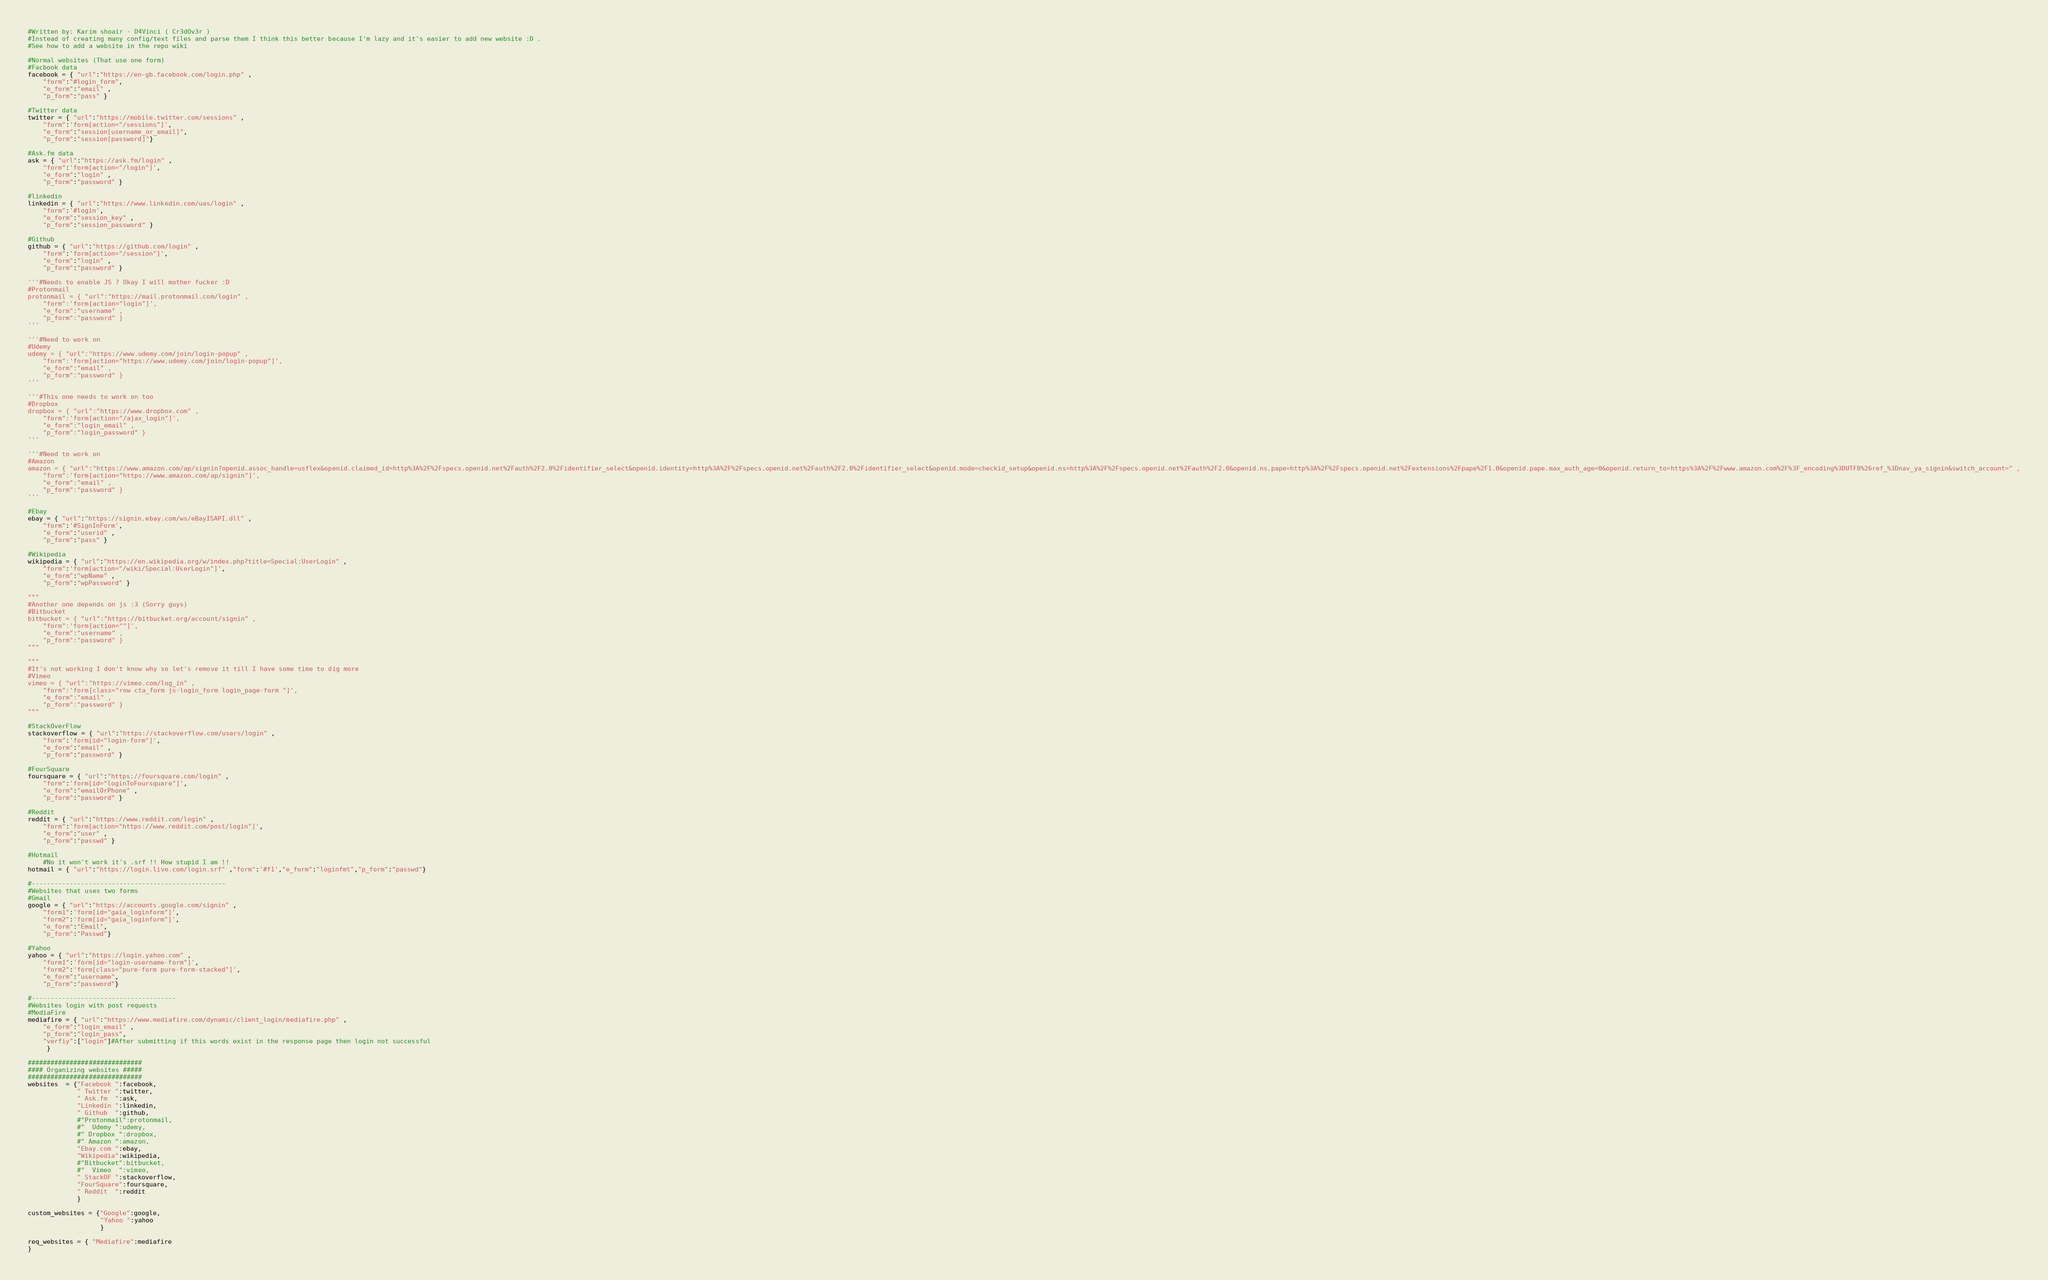<code> <loc_0><loc_0><loc_500><loc_500><_Python_>#Written by: Karim shoair - D4Vinci ( Cr3dOv3r )
#Instead of creating many config/text files and parse them I think this better because I'm lazy and it's easier to add new website :D .
#See how to add a website in the repo wiki

#Normal websites (That use one form)
#Facbook data
facebook = { "url":"https://en-gb.facebook.com/login.php" ,
	"form":"#login_form",
	"e_form":"email" ,
	"p_form":"pass" }

#Twitter data
twitter = { "url":"https://mobile.twitter.com/sessions" ,
	"form":'form[action="/sessions"]',
	"e_form":"session[username_or_email]",
	"p_form":"session[password]"}

#Ask.fm data
ask = { "url":"https://ask.fm/login" ,
	"form":'form[action="/login"]',
	"e_form":"login" ,
	"p_form":"password" }

#linkedin
linkedin = { "url":"https://www.linkedin.com/uas/login" ,
	"form":'#login',
	"e_form":"session_key" ,
	"p_form":"session_password" }

#Github
github = { "url":"https://github.com/login" ,
	"form":'form[action="/session"]',
	"e_form":"login" ,
	"p_form":"password" }

'''#Needs to enable JS ? Okay I will mother fucker :D
#Protonmail
protonmail = { "url":"https://mail.protonmail.com/login" ,
	"form":'form[action="login"]',
	"e_form":"username" ,
	"p_form":"password" }
'''

'''#Need to work on
#Udemy
udemy = { "url":"https://www.udemy.com/join/login-popup" ,
	"form":'form[action="https://www.udemy.com/join/login-popup"]',
	"e_form":"email" ,
	"p_form":"password" }
'''

'''#This one needs to work on too
#Dropbox
dropbox = { "url":"https://www.dropbox.com" ,
	"form":'form[action="/ajax_login"]',
	"e_form":"login_email" ,
	"p_form":"login_password" }
'''

'''#Need to work on
#Amazon
amazon = { "url":"https://www.amazon.com/ap/signin?openid.assoc_handle=usflex&openid.claimed_id=http%3A%2F%2Fspecs.openid.net%2Fauth%2F2.0%2Fidentifier_select&openid.identity=http%3A%2F%2Fspecs.openid.net%2Fauth%2F2.0%2Fidentifier_select&openid.mode=checkid_setup&openid.ns=http%3A%2F%2Fspecs.openid.net%2Fauth%2F2.0&openid.ns.pape=http%3A%2F%2Fspecs.openid.net%2Fextensions%2Fpape%2F1.0&openid.pape.max_auth_age=0&openid.return_to=https%3A%2F%2Fwww.amazon.com%2F%3F_encoding%3DUTF8%26ref_%3Dnav_ya_signin&switch_account=" ,
	"form":'form[action="https://www.amazon.com/ap/signin"]',
	"e_form":"email" ,
	"p_form":"password" }
'''

#Ebay
ebay = { "url":"https://signin.ebay.com/ws/eBayISAPI.dll" ,
	"form":'#SignInForm',
	"e_form":"userid" ,
	"p_form":"pass" }

#Wikipedia
wikipedia = { "url":"https://en.wikipedia.org/w/index.php?title=Special:UserLogin" ,
	"form":'form[action="/wiki/Special:UserLogin"]',
	"e_form":"wpName" ,
	"p_form":"wpPassword" }

"""
#Another one depends on js :3 (Sorry guys)
#Bitbucket
bitbucket = { "url":"https://bitbucket.org/account/signin" ,
	"form":'form[action=""]',
	"e_form":"username" ,
	"p_form":"password" }
"""

"""
#It's not working I don't know why so let's remove it till I have some time to dig more
#Vimeo
vimeo = { "url":"https://vimeo.com/log_in" ,
	"form":'form[class="row cta_form js-login_form login_page-form "]',
	"e_form":"email" ,
	"p_form":"password" }
"""

#StackOverFlow
stackoverflow = { "url":"https://stackoverflow.com/users/login" ,
	"form":'form[id="login-form"]',
	"e_form":"email" ,
	"p_form":"password" }

#FourSquare
foursquare = { "url":"https://foursquare.com/login" ,
	"form":'form[id="loginToFoursquare"]',
	"e_form":"emailOrPhone" ,
	"p_form":"password" }

#Reddit
reddit = { "url":"https://www.reddit.com/login" ,
	"form":'form[action="https://www.reddit.com/post/login"]',
	"e_form":"user" ,
	"p_form":"passwd" }

#Hotmail
	#No it won't work it's .srf !! How stupid I am !!
hotmail = { "url":"https://login.live.com/login.srf" ,"form":'#f1',"e_form":"loginfmt","p_form":"passwd"}

#---------------------------------------------------
#Websites that uses two forms
#Gmail
google = { "url":"https://accounts.google.com/signin" ,
	"form1":'form[id="gaia_loginform"]',
	"form2":'form[id="gaia_loginform"]',
	"e_form":"Email",
	"p_form":"Passwd"}

#Yahoo
yahoo = { "url":"https://login.yahoo.com" ,
	"form1":'form[id="login-username-form"]',
	"form2":'form[class="pure-form pure-form-stacked"]',
	"e_form":"username",
	"p_form":"password"}

#--------------------------------------
#Websites login with post requests
#MediaFire
mediafire = { "url":"https://www.mediafire.com/dynamic/client_login/mediafire.php" ,
	"e_form":"login_email" ,
	"p_form":"login_pass",
	"verfiy":["login"]#After submitting if this words exist in the response page then login not successful
	 }

##############################
#### Organizing websites #####
##############################
websites  = {"Facebook ":facebook,
			 " Twitter ":twitter,
			 " Ask.fm  ":ask,
			 "Linkedin ":linkedin,
			 " Github  ":github,
             #"Protonmail":protonmail,
             #"  Udemy ":udemy,
             #" Dropbox ":dropbox,
             #" Amazon ":amazon,
             "Ebay.com ":ebay,
             "Wikipedia":wikipedia,
             #"Bitbucket":bitbucket,
             #"  Vimeo  ":vimeo,
             " StackOF ":stackoverflow,
             "FourSquare":foursquare,
             " Reddit  ":reddit
			 }

custom_websites = {"Google":google,
				   "Yahoo ":yahoo
				   }

req_websites = { "Mediafire":mediafire
}
</code> 